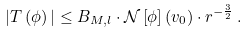<formula> <loc_0><loc_0><loc_500><loc_500>| T \left ( \phi \right ) | \leq B _ { M , l } \cdot \mathcal { N } \left [ \phi \right ] \left ( v _ { 0 } \right ) \cdot r ^ { - \frac { 3 } { 2 } } \, .</formula> 